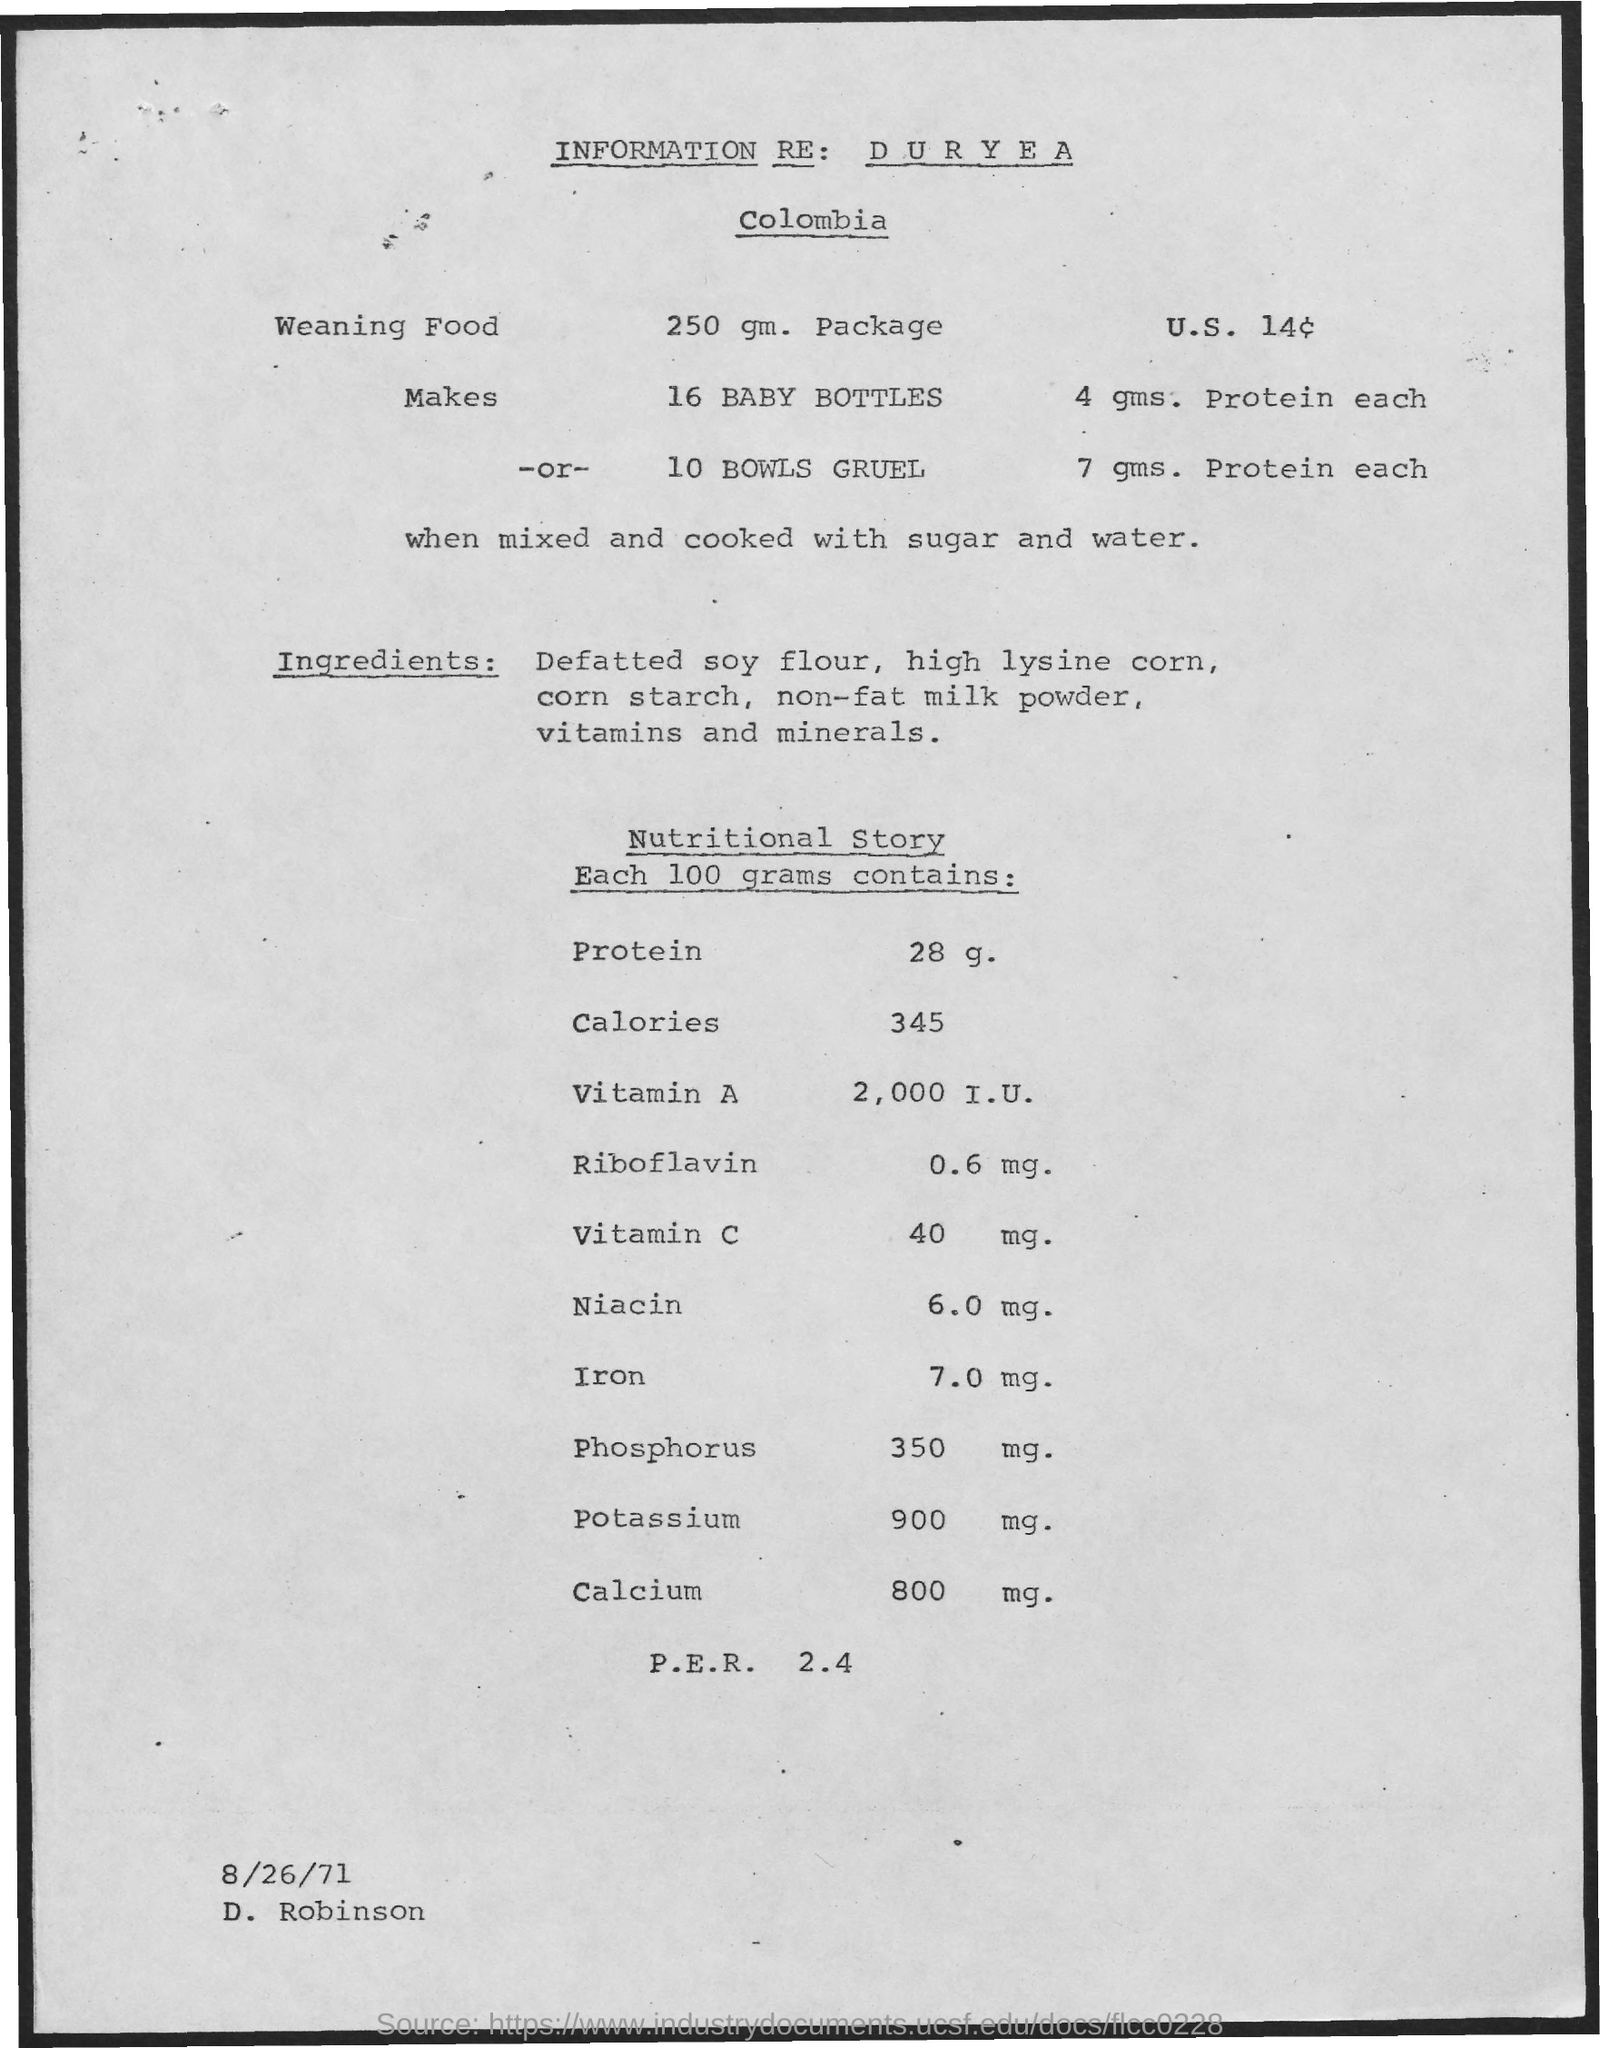Give some essential details in this illustration. What is the date mentioned? August 26, 1971. The person mentioned is D. Robinson. 